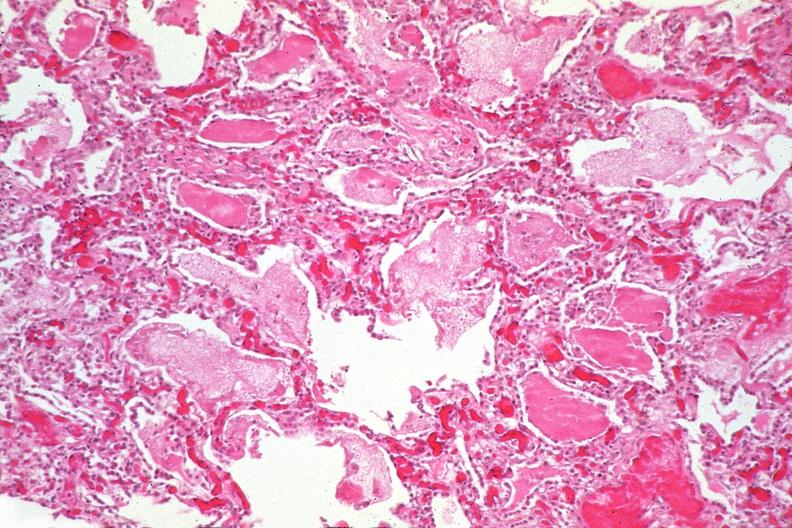s respiratory present?
Answer the question using a single word or phrase. Yes 